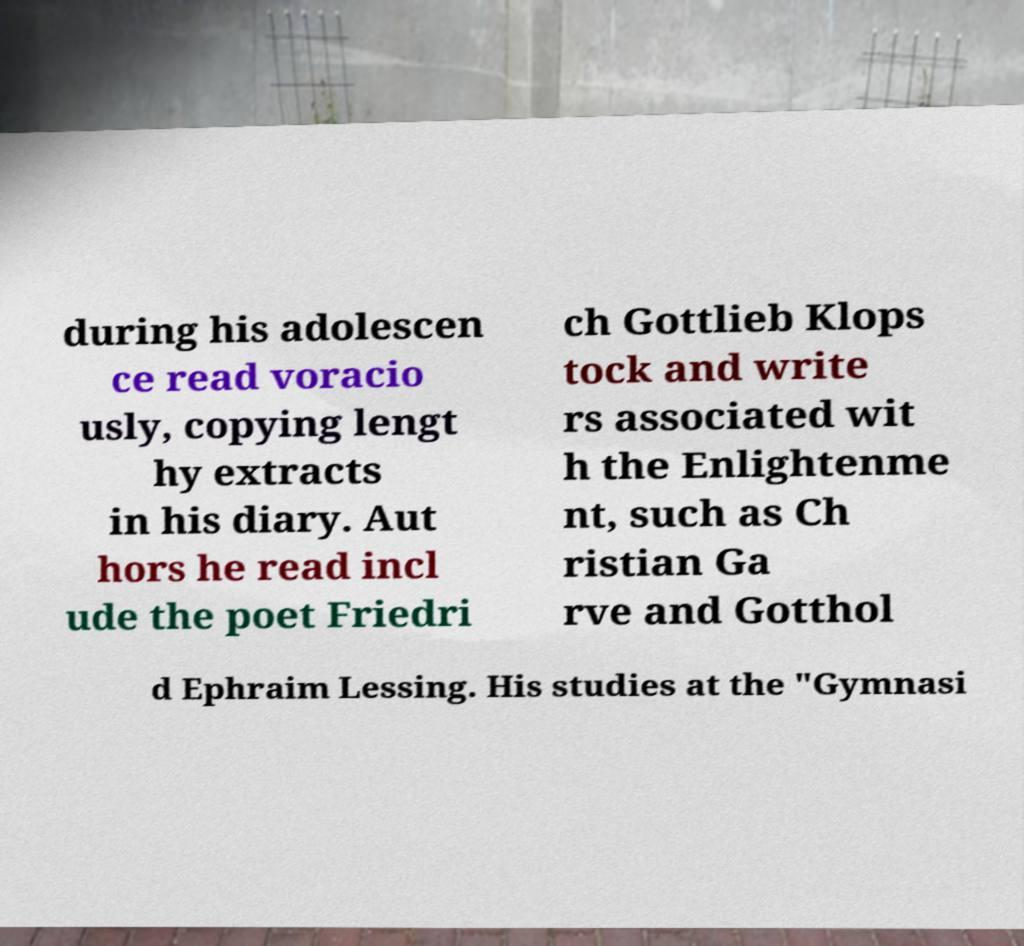What messages or text are displayed in this image? I need them in a readable, typed format. during his adolescen ce read voracio usly, copying lengt hy extracts in his diary. Aut hors he read incl ude the poet Friedri ch Gottlieb Klops tock and write rs associated wit h the Enlightenme nt, such as Ch ristian Ga rve and Gotthol d Ephraim Lessing. His studies at the "Gymnasi 